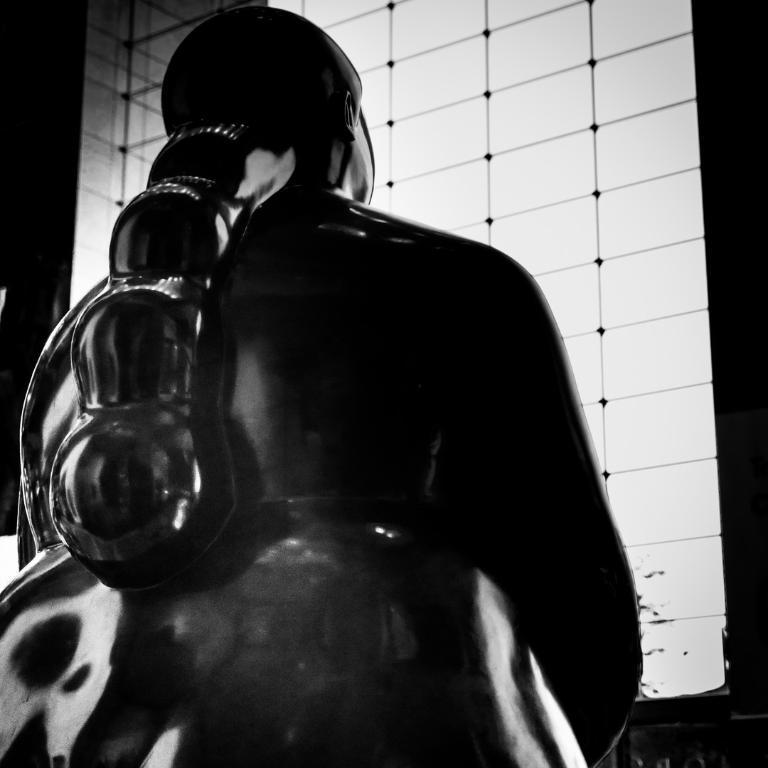What is the main subject in the front of the image? There is a statue in the front of the image. Can you describe the statue in the background? There is another statue in the background of the image. What is the color scheme of the image? The image is black and white. Can you tell me how many kittens are playing with a piece of paper in the image? There are no kittens or pieces of paper present in the image; it features two statues in a black and white color scheme. 